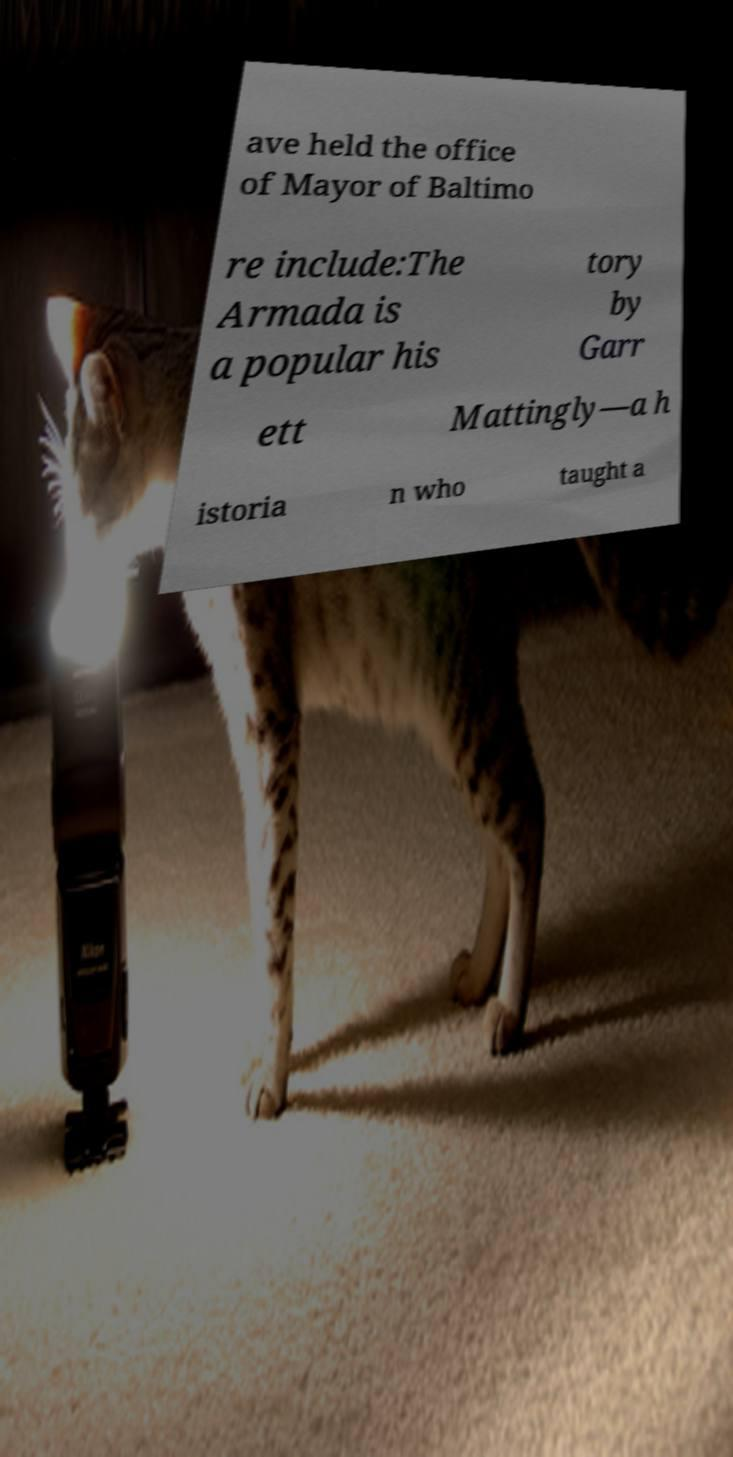Could you extract and type out the text from this image? ave held the office of Mayor of Baltimo re include:The Armada is a popular his tory by Garr ett Mattingly—a h istoria n who taught a 